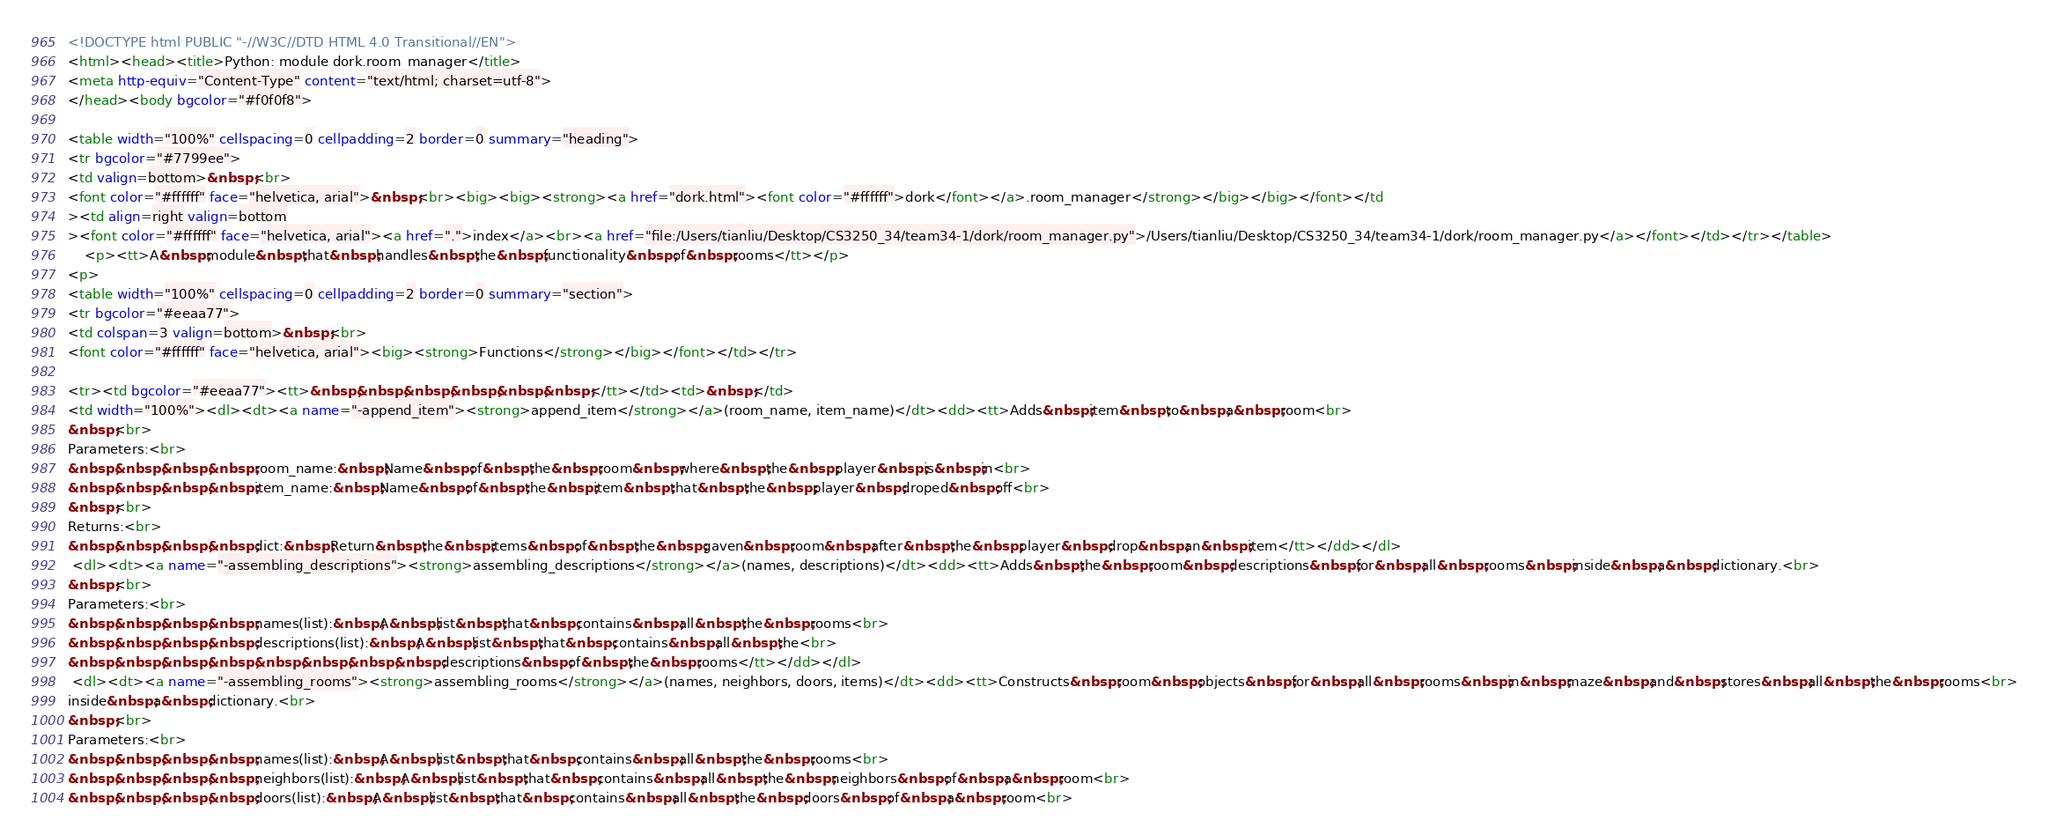<code> <loc_0><loc_0><loc_500><loc_500><_HTML_><!DOCTYPE html PUBLIC "-//W3C//DTD HTML 4.0 Transitional//EN">
<html><head><title>Python: module dork.room_manager</title>
<meta http-equiv="Content-Type" content="text/html; charset=utf-8">
</head><body bgcolor="#f0f0f8">

<table width="100%" cellspacing=0 cellpadding=2 border=0 summary="heading">
<tr bgcolor="#7799ee">
<td valign=bottom>&nbsp;<br>
<font color="#ffffff" face="helvetica, arial">&nbsp;<br><big><big><strong><a href="dork.html"><font color="#ffffff">dork</font></a>.room_manager</strong></big></big></font></td
><td align=right valign=bottom
><font color="#ffffff" face="helvetica, arial"><a href=".">index</a><br><a href="file:/Users/tianliu/Desktop/CS3250_34/team34-1/dork/room_manager.py">/Users/tianliu/Desktop/CS3250_34/team34-1/dork/room_manager.py</a></font></td></tr></table>
    <p><tt>A&nbsp;module&nbsp;that&nbsp;handles&nbsp;the&nbsp;functionality&nbsp;of&nbsp;rooms</tt></p>
<p>
<table width="100%" cellspacing=0 cellpadding=2 border=0 summary="section">
<tr bgcolor="#eeaa77">
<td colspan=3 valign=bottom>&nbsp;<br>
<font color="#ffffff" face="helvetica, arial"><big><strong>Functions</strong></big></font></td></tr>
    
<tr><td bgcolor="#eeaa77"><tt>&nbsp;&nbsp;&nbsp;&nbsp;&nbsp;&nbsp;</tt></td><td>&nbsp;</td>
<td width="100%"><dl><dt><a name="-append_item"><strong>append_item</strong></a>(room_name, item_name)</dt><dd><tt>Adds&nbsp;item&nbsp;to&nbsp;a&nbsp;room<br>
&nbsp;<br>
Parameters:<br>
&nbsp;&nbsp;&nbsp;&nbsp;room_name:&nbsp;Name&nbsp;of&nbsp;the&nbsp;room&nbsp;where&nbsp;the&nbsp;player&nbsp;is&nbsp;in<br>
&nbsp;&nbsp;&nbsp;&nbsp;item_name:&nbsp;Name&nbsp;of&nbsp;the&nbsp;item&nbsp;that&nbsp;the&nbsp;player&nbsp;droped&nbsp;off<br>
&nbsp;<br>
Returns:<br>
&nbsp;&nbsp;&nbsp;&nbsp;dict:&nbsp;Return&nbsp;the&nbsp;items&nbsp;of&nbsp;the&nbsp;gaven&nbsp;room&nbsp;after&nbsp;the&nbsp;player&nbsp;drop&nbsp;an&nbsp;item</tt></dd></dl>
 <dl><dt><a name="-assembling_descriptions"><strong>assembling_descriptions</strong></a>(names, descriptions)</dt><dd><tt>Adds&nbsp;the&nbsp;room&nbsp;descriptions&nbsp;for&nbsp;all&nbsp;rooms&nbsp;inside&nbsp;a&nbsp;dictionary.<br>
&nbsp;<br>
Parameters:<br>
&nbsp;&nbsp;&nbsp;&nbsp;names(list):&nbsp;A&nbsp;list&nbsp;that&nbsp;contains&nbsp;all&nbsp;the&nbsp;rooms<br>
&nbsp;&nbsp;&nbsp;&nbsp;descriptions(list):&nbsp;A&nbsp;list&nbsp;that&nbsp;contains&nbsp;all&nbsp;the<br>
&nbsp;&nbsp;&nbsp;&nbsp;&nbsp;&nbsp;&nbsp;&nbsp;descriptions&nbsp;of&nbsp;the&nbsp;rooms</tt></dd></dl>
 <dl><dt><a name="-assembling_rooms"><strong>assembling_rooms</strong></a>(names, neighbors, doors, items)</dt><dd><tt>Constructs&nbsp;room&nbsp;objects&nbsp;for&nbsp;all&nbsp;rooms&nbsp;in&nbsp;maze&nbsp;and&nbsp;stores&nbsp;all&nbsp;the&nbsp;rooms<br>
inside&nbsp;a&nbsp;dictionary.<br>
&nbsp;<br>
Parameters:<br>
&nbsp;&nbsp;&nbsp;&nbsp;names(list):&nbsp;A&nbsp;list&nbsp;that&nbsp;contains&nbsp;all&nbsp;the&nbsp;rooms<br>
&nbsp;&nbsp;&nbsp;&nbsp;neighbors(list):&nbsp;A&nbsp;list&nbsp;that&nbsp;contains&nbsp;all&nbsp;the&nbsp;neighbors&nbsp;of&nbsp;a&nbsp;room<br>
&nbsp;&nbsp;&nbsp;&nbsp;doors(list):&nbsp;A&nbsp;list&nbsp;that&nbsp;contains&nbsp;all&nbsp;the&nbsp;doors&nbsp;of&nbsp;a&nbsp;room<br></code> 